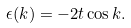Convert formula to latex. <formula><loc_0><loc_0><loc_500><loc_500>\epsilon ( k ) = - 2 t \cos k .</formula> 